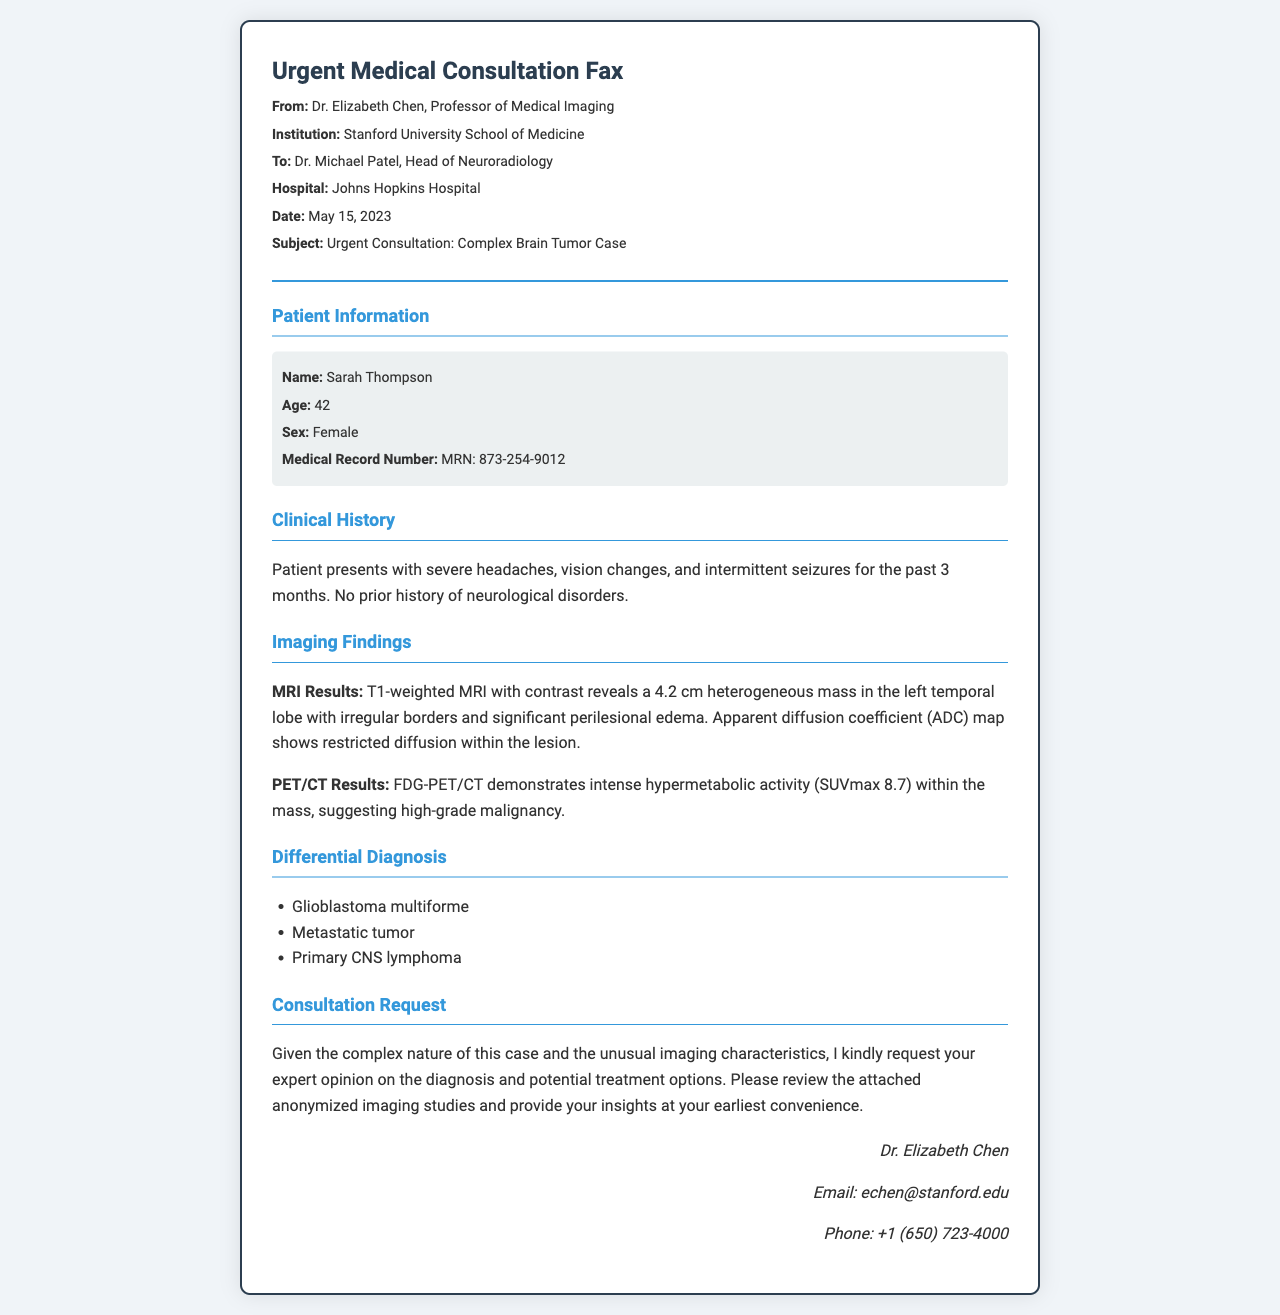what is the patient's name? The document provides the name of the patient in the patient information section, which is Sarah Thompson.
Answer: Sarah Thompson what is the patient's age? The age of the patient is listed under patient information, which shows she is 42 years old.
Answer: 42 who is the recipient of the fax? The recipient is indicated at the start of the document and is Dr. Michael Patel, Head of Neuroradiology.
Answer: Dr. Michael Patel what is the date of the fax? The fax states the date it was sent, which is May 15, 2023.
Answer: May 15, 2023 what imaging technique was used to reveal the mass? The document specifies that a T1-weighted MRI with contrast was used to identify the mass in the patient's brain.
Answer: T1-weighted MRI with contrast what is the size of the mass identified in the MRI results? The document indicates the size of the mass found on the MRI is 4.2 cm.
Answer: 4.2 cm what does the PET/CT show about the mass? The PET/CT findings indicate intense hypermetabolic activity, which suggests high-grade malignancy as reported within the document.
Answer: high-grade malignancy what differential diagnosis is suggested for the patient's condition? The document lists possible conditions including glioblastoma multiforme, metastatic tumor, and primary CNS lymphoma as differential diagnoses.
Answer: glioblastoma multiforme what is the main reason for the consultation request? The fax requests consultation due to the complex nature of the case and unusual imaging characteristics of the mass.
Answer: complex nature and unusual imaging characteristics 